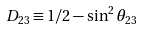<formula> <loc_0><loc_0><loc_500><loc_500>D _ { 2 3 } \equiv 1 / 2 - \sin ^ { 2 } \theta _ { 2 3 }</formula> 